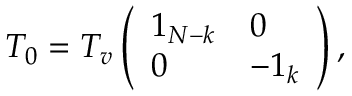Convert formula to latex. <formula><loc_0><loc_0><loc_500><loc_500>T _ { 0 } = T _ { v } \left ( \begin{array} { l l } { { 1 _ { N - k } } } & { 0 } \\ { 0 } & { { - 1 _ { k } } } \end{array} \right ) ,</formula> 